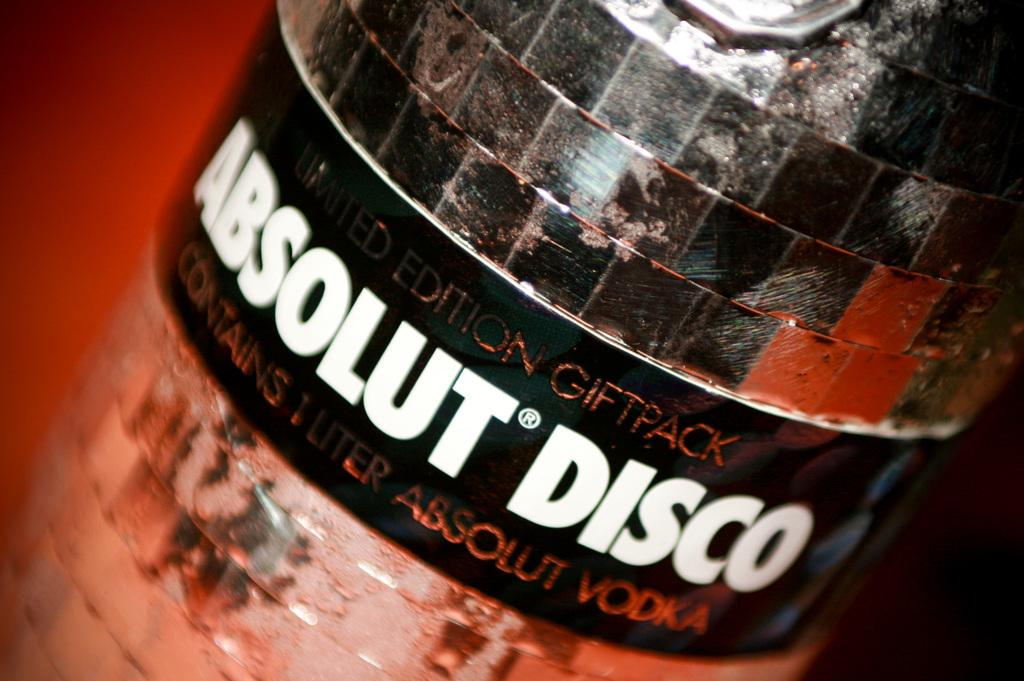<image>
Provide a brief description of the given image. a bottle of liquor called absolut disco which is vodka 